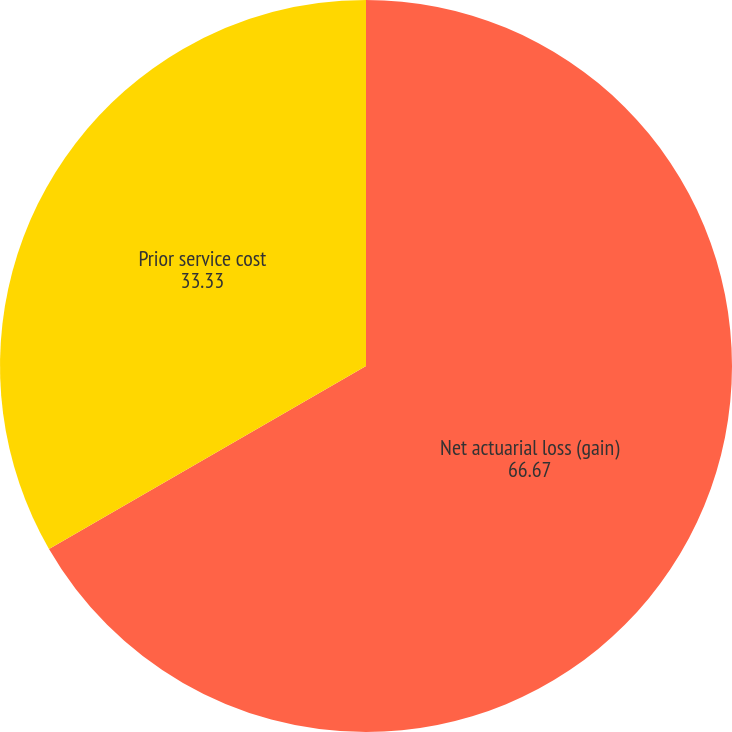Convert chart to OTSL. <chart><loc_0><loc_0><loc_500><loc_500><pie_chart><fcel>Net actuarial loss (gain)<fcel>Prior service cost<nl><fcel>66.67%<fcel>33.33%<nl></chart> 